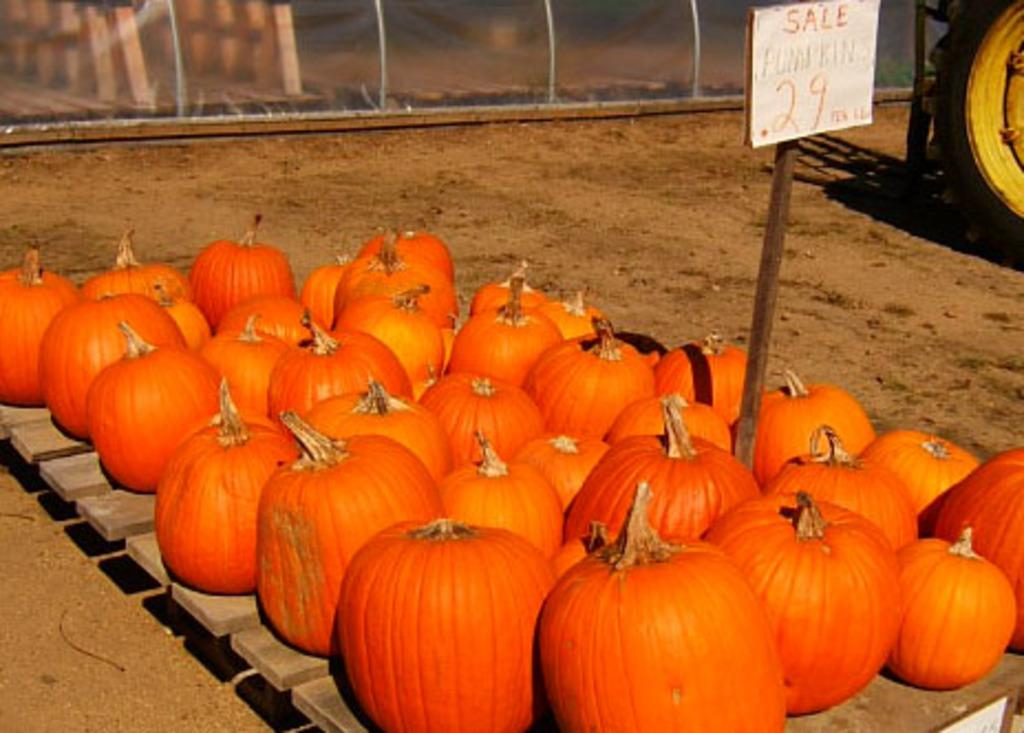What objects are on the wooden surface in the image? There are pumpkins on a wooden surface in the image. What type of surface is the pumpkins placed on? The wooden surface is a wooden table or platform. What can be seen on the ground in the image? There is sand visible on the ground in the image. What might be the setting or location of the image? The presence of sand suggests that the image might be taken at a beach or a sandy area. What channel is the knee being offered on in the image? There is no channel or knee present in the image; it features pumpkins on a wooden surface and sand on the ground. 